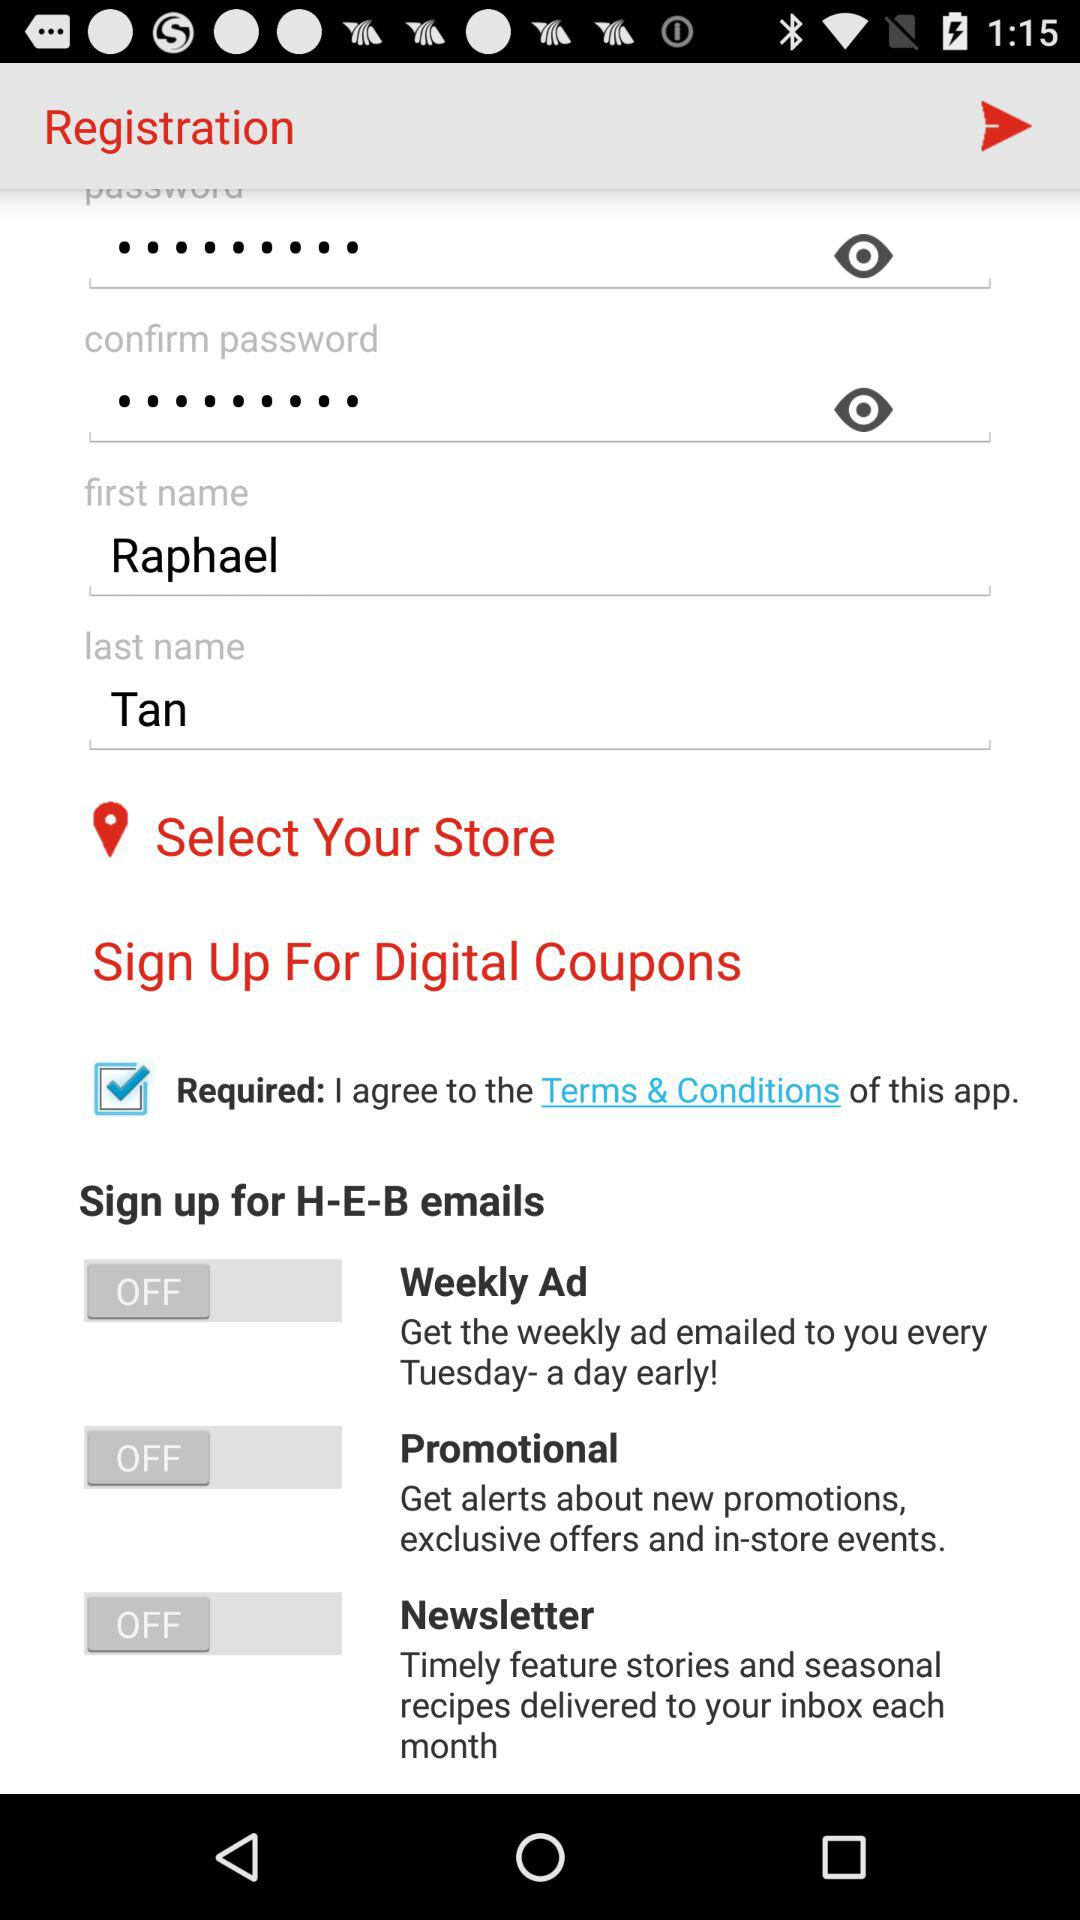What is the status of the "Newsletter"? The status of the "Newsletter" is "off". 